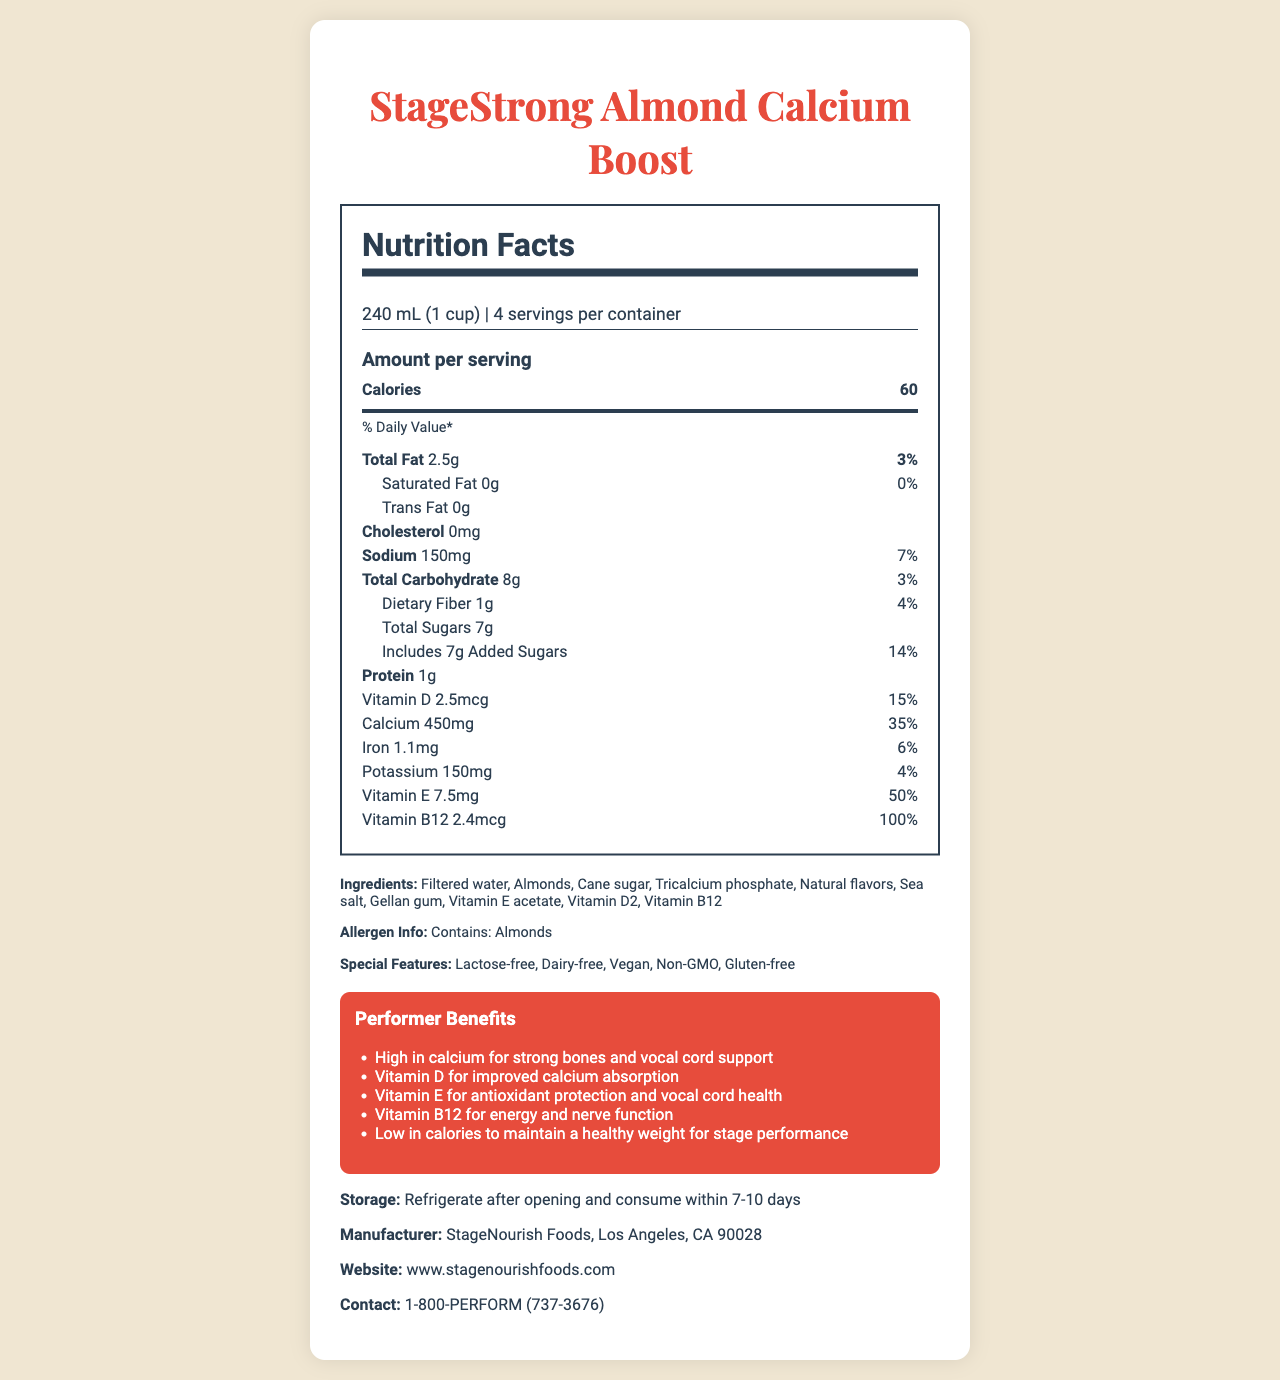what is the serving size? The serving size is prominently displayed at the top of the Nutrition Facts section as "240 mL (1 cup)".
Answer: 240 mL (1 cup) how many servings are there per container? This information is located below the serving size and is indicated as "4 servings per container".
Answer: 4 what is the amount of calcium per serving? The amount of calcium per serving is listed under the nutrients section, showing "Calcium 450mg".
Answer: 450mg what are the main allergens in this product? The allergen information is listed explicitly with "Contains: Almonds" under the ingredients section.
Answer: Contains: Almonds what is the percentage of daily value for vitamin B12? This information is found in the Nutrition Facts section under the nutrients, where it states "Vitamin B12 100%".
Answer: 100% how many grams of protein are in one serving? The protein content per serving is listed in the Nutrition Facts section as "Protein 1g".
Answer: 1g which special feature is not listed for this product? A. Lactose-free B. Organic C. Vegan The special features listed are "Lactose-free", "Dairy-free", "Vegan", "Non-GMO", and "Gluten-free". "Organic" is not mentioned.
Answer: B. Organic what is the total fat content per serving? A. 0g B. 1g C. 2.5g D. 3g The total fat content is listed as "Total Fat 2.5g" in the Nutrition Facts section.
Answer: C. 2.5g is the product gluten-free? The special features section lists "Gluten-free" as one of the qualities.
Answer: Yes describe the main nutritional benefits tailored for performers. The performer benefits section provides a detailed list of benefits tailored for performers, highlighting specific vitamins and their corresponding advantages.
Answer: The product is high in calcium for strong bones and vocal cord support, contains vitamin D for improved calcium absorption, vitamin E for antioxidant protection and vocal cord health, and vitamin B12 for energy and nerve function. It is also low in calories to help maintain a healthy weight for stage performance. what is the sugar content in this product? The total sugar content is listed under the nutrients section as "Total Sugars 7g".
Answer: 7g does this product contain cholesterol? The cholesterol content is listed as "0mg" in the Nutrition Facts section, indicating it contains no cholesterol.
Answer: No what is the company's contact number? The contact number is provided at the end of the document under the contact section.
Answer: 1-800-PERFORM (737-3676) which preservative is used in this product? The document does not explicitly mention any preservatives used in the product, only listing ingredients like "Gellan gum" which is not always considered a preservative.
Answer: Not enough information what is the main idea of the document? The document focuses on the nutritional content, special features, and benefits tailored for performers as well as providing storage and manufacturer information.
Answer: The document provides detailed nutritional information about "StageStrong Almond Calcium Boost", a lactose-free, dairy-free milk alternative designed for performers. It highlights its benefits, special features, ingredients, and contact details. 